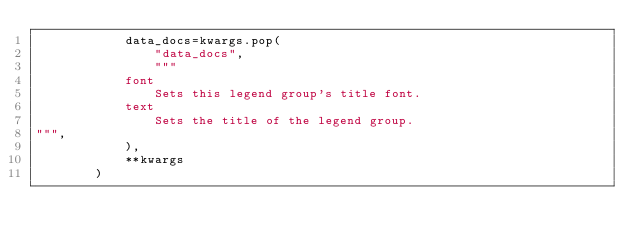<code> <loc_0><loc_0><loc_500><loc_500><_Python_>            data_docs=kwargs.pop(
                "data_docs",
                """
            font
                Sets this legend group's title font.
            text
                Sets the title of the legend group.
""",
            ),
            **kwargs
        )
</code> 